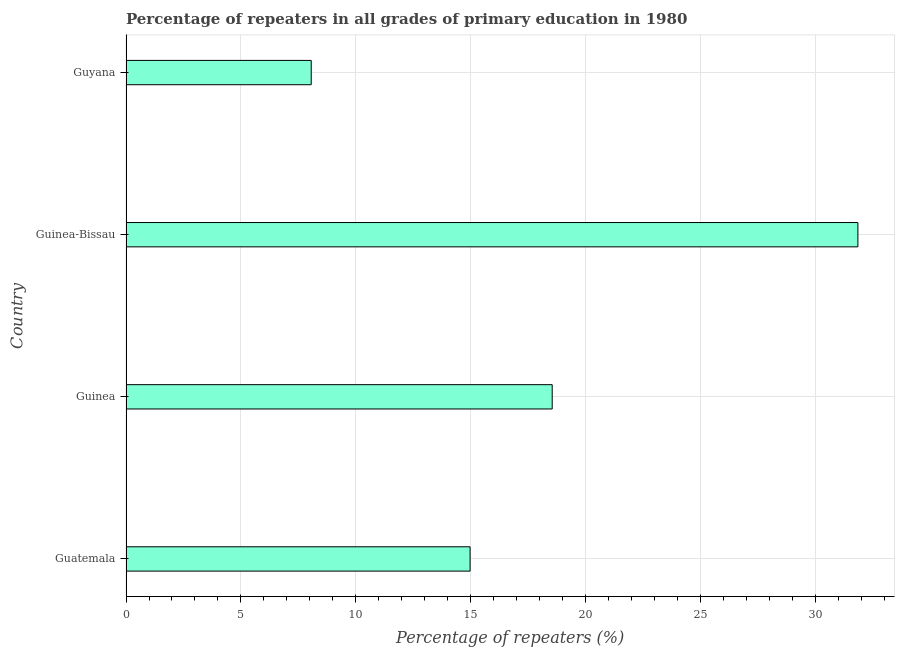Does the graph contain grids?
Offer a terse response. Yes. What is the title of the graph?
Give a very brief answer. Percentage of repeaters in all grades of primary education in 1980. What is the label or title of the X-axis?
Make the answer very short. Percentage of repeaters (%). What is the percentage of repeaters in primary education in Guatemala?
Give a very brief answer. 14.97. Across all countries, what is the maximum percentage of repeaters in primary education?
Your answer should be compact. 31.85. Across all countries, what is the minimum percentage of repeaters in primary education?
Keep it short and to the point. 8.06. In which country was the percentage of repeaters in primary education maximum?
Your answer should be very brief. Guinea-Bissau. In which country was the percentage of repeaters in primary education minimum?
Your answer should be very brief. Guyana. What is the sum of the percentage of repeaters in primary education?
Keep it short and to the point. 73.42. What is the difference between the percentage of repeaters in primary education in Guatemala and Guyana?
Your response must be concise. 6.91. What is the average percentage of repeaters in primary education per country?
Provide a short and direct response. 18.36. What is the median percentage of repeaters in primary education?
Your answer should be compact. 16.76. In how many countries, is the percentage of repeaters in primary education greater than 1 %?
Your response must be concise. 4. What is the ratio of the percentage of repeaters in primary education in Guatemala to that in Guyana?
Your response must be concise. 1.86. Is the percentage of repeaters in primary education in Guinea less than that in Guyana?
Your answer should be compact. No. Is the difference between the percentage of repeaters in primary education in Guinea-Bissau and Guyana greater than the difference between any two countries?
Keep it short and to the point. Yes. What is the difference between the highest and the second highest percentage of repeaters in primary education?
Your answer should be compact. 13.3. Is the sum of the percentage of repeaters in primary education in Guinea and Guyana greater than the maximum percentage of repeaters in primary education across all countries?
Ensure brevity in your answer.  No. What is the difference between the highest and the lowest percentage of repeaters in primary education?
Your answer should be very brief. 23.79. In how many countries, is the percentage of repeaters in primary education greater than the average percentage of repeaters in primary education taken over all countries?
Provide a short and direct response. 2. How many bars are there?
Give a very brief answer. 4. Are all the bars in the graph horizontal?
Keep it short and to the point. Yes. Are the values on the major ticks of X-axis written in scientific E-notation?
Offer a very short reply. No. What is the Percentage of repeaters (%) of Guatemala?
Keep it short and to the point. 14.97. What is the Percentage of repeaters (%) of Guinea?
Provide a succinct answer. 18.54. What is the Percentage of repeaters (%) in Guinea-Bissau?
Give a very brief answer. 31.85. What is the Percentage of repeaters (%) in Guyana?
Keep it short and to the point. 8.06. What is the difference between the Percentage of repeaters (%) in Guatemala and Guinea?
Offer a terse response. -3.57. What is the difference between the Percentage of repeaters (%) in Guatemala and Guinea-Bissau?
Make the answer very short. -16.87. What is the difference between the Percentage of repeaters (%) in Guatemala and Guyana?
Keep it short and to the point. 6.91. What is the difference between the Percentage of repeaters (%) in Guinea and Guinea-Bissau?
Provide a succinct answer. -13.3. What is the difference between the Percentage of repeaters (%) in Guinea and Guyana?
Make the answer very short. 10.49. What is the difference between the Percentage of repeaters (%) in Guinea-Bissau and Guyana?
Make the answer very short. 23.79. What is the ratio of the Percentage of repeaters (%) in Guatemala to that in Guinea?
Ensure brevity in your answer.  0.81. What is the ratio of the Percentage of repeaters (%) in Guatemala to that in Guinea-Bissau?
Provide a succinct answer. 0.47. What is the ratio of the Percentage of repeaters (%) in Guatemala to that in Guyana?
Offer a very short reply. 1.86. What is the ratio of the Percentage of repeaters (%) in Guinea to that in Guinea-Bissau?
Make the answer very short. 0.58. What is the ratio of the Percentage of repeaters (%) in Guinea to that in Guyana?
Your answer should be very brief. 2.3. What is the ratio of the Percentage of repeaters (%) in Guinea-Bissau to that in Guyana?
Your response must be concise. 3.95. 